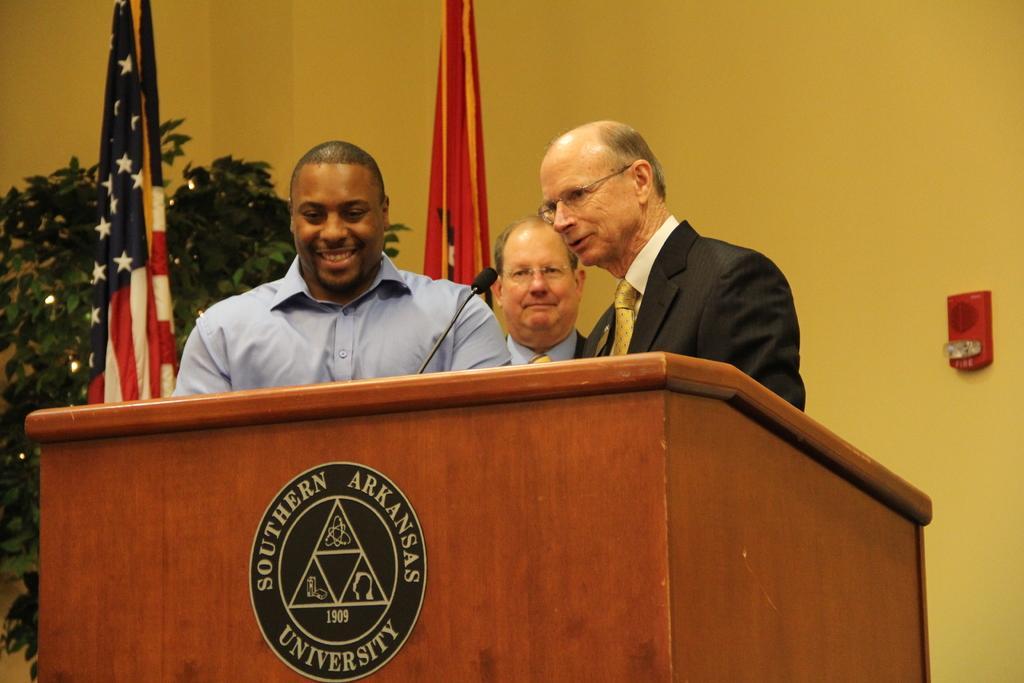Describe this image in one or two sentences. There are three persons standing. Two are wearing specs. Also there is a podium with mic. On the podium there is an emblem with something written. In the back there are flags and a plant. In the background there is a wall with alarm. 